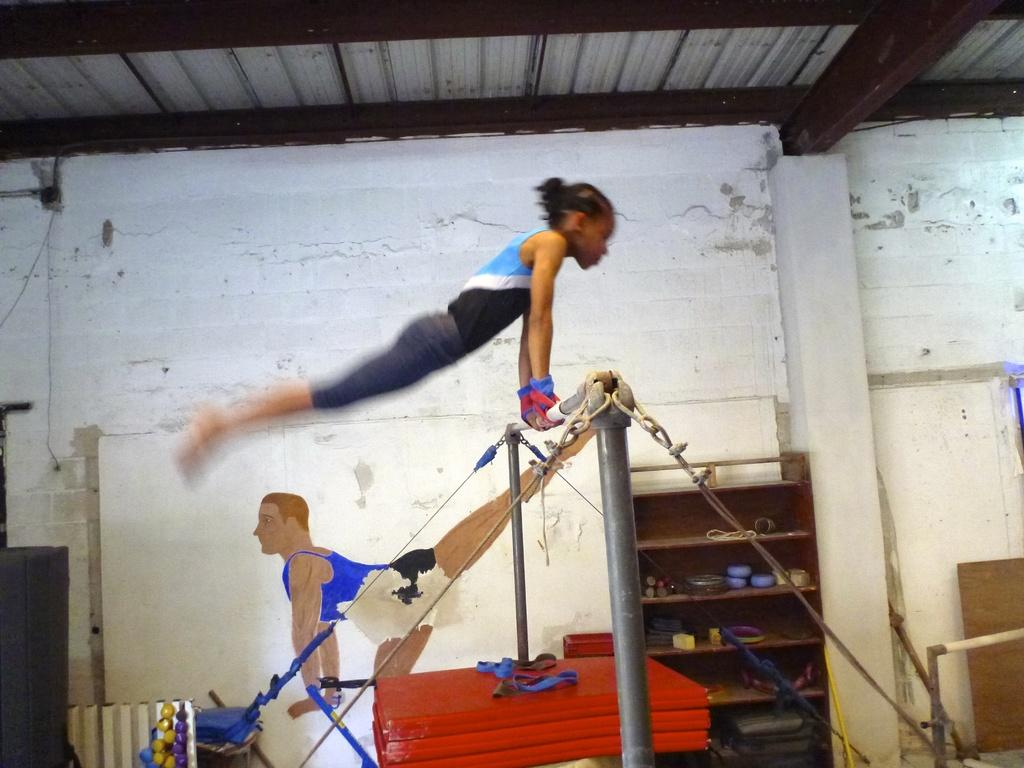What is the woman doing in the image? The woman is on a pole in the image. What can be seen on the shelves in the image? There are bowls, glasses, cups, and other objects on the shelves in the image. What is visible in the background of the image? There is a wall in the background of the image. What type of produce is being stored in the crib in the image? There is no crib or produce present in the image. Where is the nest located in the image? There is no nest present in the image. 